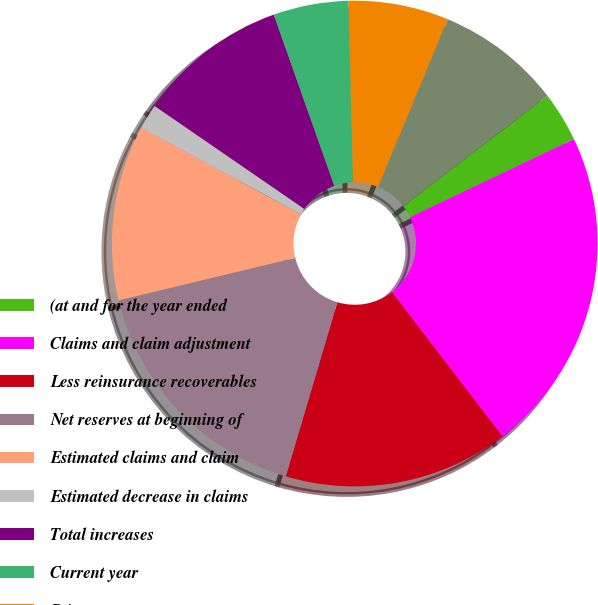Convert chart to OTSL. <chart><loc_0><loc_0><loc_500><loc_500><pie_chart><fcel>(at and for the year ended<fcel>Claims and claim adjustment<fcel>Less reinsurance recoverables<fcel>Net reserves at beginning of<fcel>Estimated claims and claim<fcel>Estimated decrease in claims<fcel>Total increases<fcel>Current year<fcel>Prior years<fcel>Total payments<nl><fcel>3.34%<fcel>21.66%<fcel>15.0%<fcel>16.66%<fcel>11.67%<fcel>1.67%<fcel>10.0%<fcel>5.0%<fcel>6.67%<fcel>8.33%<nl></chart> 